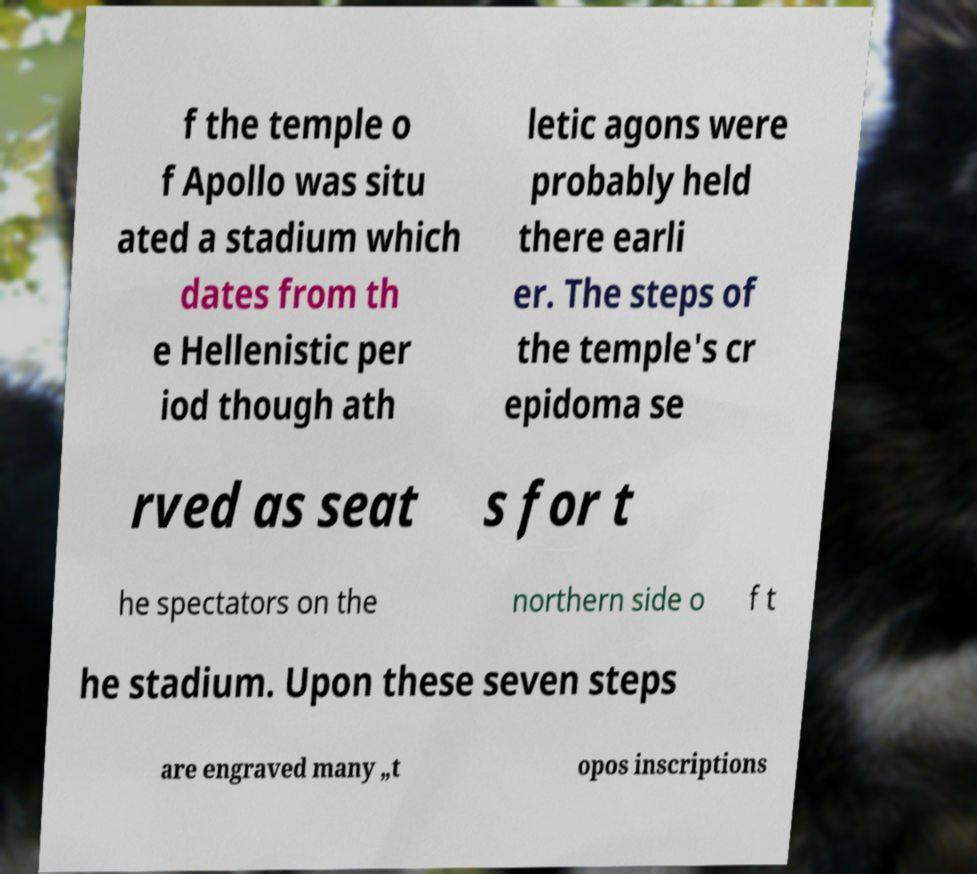For documentation purposes, I need the text within this image transcribed. Could you provide that? f the temple o f Apollo was situ ated a stadium which dates from th e Hellenistic per iod though ath letic agons were probably held there earli er. The steps of the temple's cr epidoma se rved as seat s for t he spectators on the northern side o f t he stadium. Upon these seven steps are engraved many „t opos inscriptions 